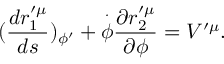Convert formula to latex. <formula><loc_0><loc_0><loc_500><loc_500>( \frac { d r _ { 1 } ^ { \prime \mu } } { d s } ) _ { \phi ^ { \prime } } + \overset { \cdot } { \phi } \frac { \partial r _ { 2 } ^ { \prime \mu } } { \partial \phi } = V ^ { \prime \mu } .</formula> 